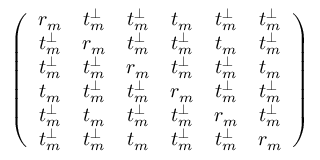<formula> <loc_0><loc_0><loc_500><loc_500>\left ( \begin{array} { c c c c c c } { r _ { m } } & { t _ { m } ^ { \perp } } & { t _ { m } ^ { \perp } } & { t _ { m } } & { t _ { m } ^ { \perp } } & { t _ { m } ^ { \perp } } \\ { t _ { m } ^ { \perp } } & { r _ { m } } & { t _ { m } ^ { \perp } } & { t _ { m } ^ { \perp } } & { t _ { m } } & { t _ { m } ^ { \perp } } \\ { t _ { m } ^ { \perp } } & { t _ { m } ^ { \perp } } & { r _ { m } } & { t _ { m } ^ { \perp } } & { t _ { m } ^ { \perp } } & { t _ { m } } \\ { t _ { m } } & { t _ { m } ^ { \perp } } & { t _ { m } ^ { \perp } } & { r _ { m } } & { t _ { m } ^ { \perp } } & { t _ { m } ^ { \perp } } \\ { t _ { m } ^ { \perp } } & { t _ { m } } & { t _ { m } ^ { \perp } } & { t _ { m } ^ { \perp } } & { r _ { m } } & { t _ { m } ^ { \perp } } \\ { t _ { m } ^ { \perp } } & { t _ { m } ^ { \perp } } & { t _ { m } } & { t _ { m } ^ { \perp } } & { t _ { m } ^ { \perp } } & { r _ { m } } \end{array} \right )</formula> 